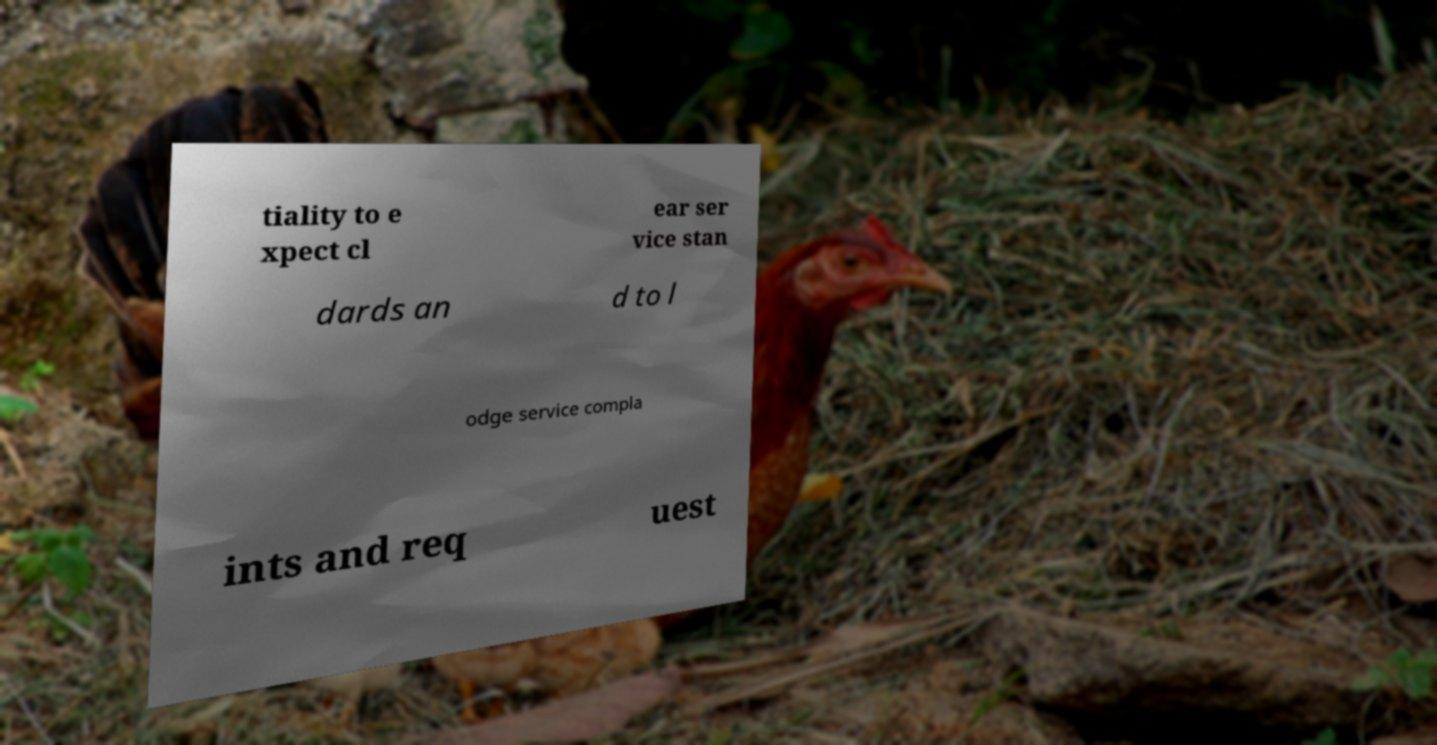I need the written content from this picture converted into text. Can you do that? tiality to e xpect cl ear ser vice stan dards an d to l odge service compla ints and req uest 